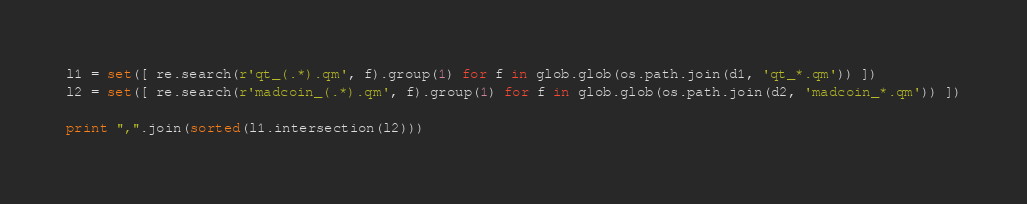<code> <loc_0><loc_0><loc_500><loc_500><_Python_>l1 = set([ re.search(r'qt_(.*).qm', f).group(1) for f in glob.glob(os.path.join(d1, 'qt_*.qm')) ])
l2 = set([ re.search(r'madcoin_(.*).qm', f).group(1) for f in glob.glob(os.path.join(d2, 'madcoin_*.qm')) ])

print ",".join(sorted(l1.intersection(l2)))

</code> 